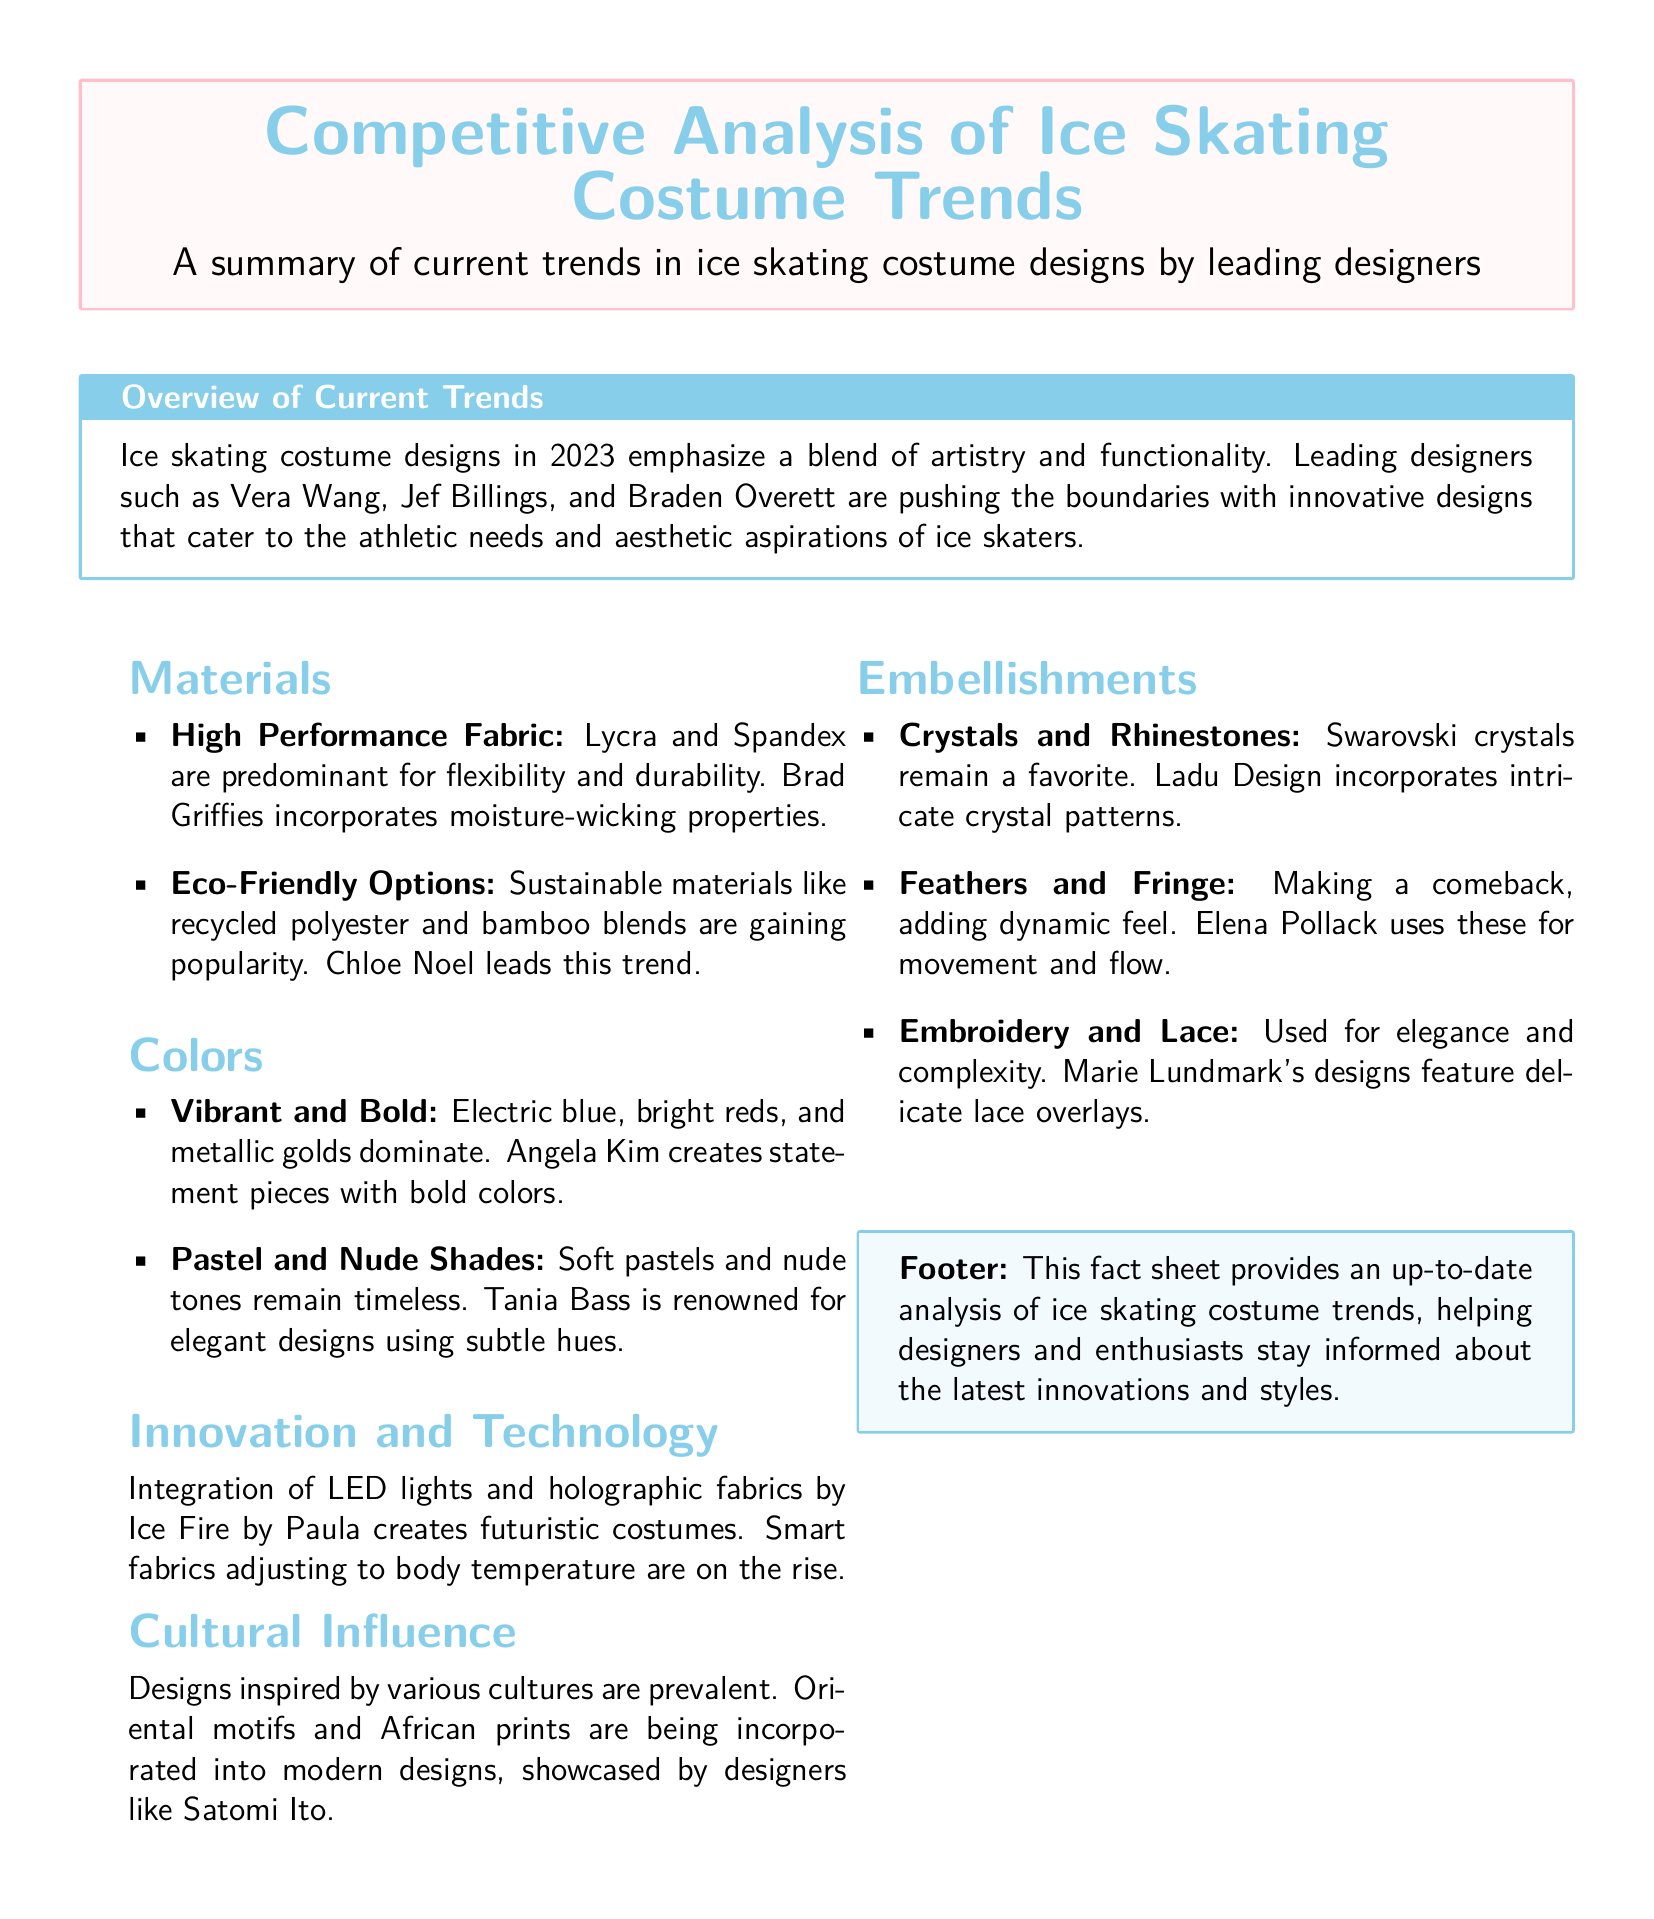What are the leading designers mentioned? The document lists Vera Wang, Jef Billings, Braden Overett, Chloe Noel, Angela Kim, Tania Bass, Satomi Ito, Ice Fire by Paula, Ladu Design, Elena Pollack, and Marie Lundmark.
Answer: Vera Wang, Jef Billings, Braden Overett, Chloe Noel, Angela Kim, Tania Bass, Satomi Ito, Ice Fire by Paula, Ladu Design, Elena Pollack, Marie Lundmark What materials are predominantly used in costume designs? The document mentions Lycra and Spandex as the predominant materials for flexibility and durability.
Answer: Lycra and Spandex Which color is noted for dominating ice skating costumes? The document states that electric blue, bright reds, and metallic golds dominate the designs.
Answer: Electric blue, bright reds, metallic golds What embellishments are making a comeback? The document highlights that feathers and fringe are making a comeback in costume designs.
Answer: Feathers and Fringe Which trend is associated with Chloe Noel? The document indicates that Chloe Noel is leading the trend for using sustainable materials like recycled polyester and bamboo blends.
Answer: Eco-Friendly Options What innovative feature is incorporated in costumes by Ice Fire by Paula? The document mentions that Ice Fire by Paula integrates LED lights and holographic fabrics into costume designs.
Answer: LED lights and holographic fabrics What is the primary purpose of the fact sheet? The primary purpose is to provide an up-to-date analysis of ice skating costume trends to inform designers and enthusiasts.
Answer: To inform designers and enthusiasts What kind of cultural influence is seen in current designs? The document states that designs inspired by various cultures, including oriental motifs and African prints, are prevalent.
Answer: Oriental motifs and African prints 